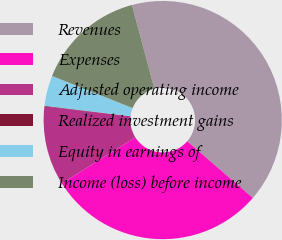Convert chart to OTSL. <chart><loc_0><loc_0><loc_500><loc_500><pie_chart><fcel>Revenues<fcel>Expenses<fcel>Adjusted operating income<fcel>Realized investment gains<fcel>Equity in earnings of<fcel>Income (loss) before income<nl><fcel>40.5%<fcel>29.73%<fcel>10.76%<fcel>0.08%<fcel>4.12%<fcel>14.8%<nl></chart> 